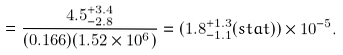Convert formula to latex. <formula><loc_0><loc_0><loc_500><loc_500>= \frac { 4 . 5 ^ { + 3 . 4 } _ { - 2 . 8 } } { ( 0 . 1 6 6 ) ( 1 . 5 2 \times 1 0 ^ { 6 } ) } = ( 1 . 8 ^ { + 1 . 3 } _ { - 1 . 1 } ( s t a t ) ) \times 1 0 ^ { - 5 } .</formula> 